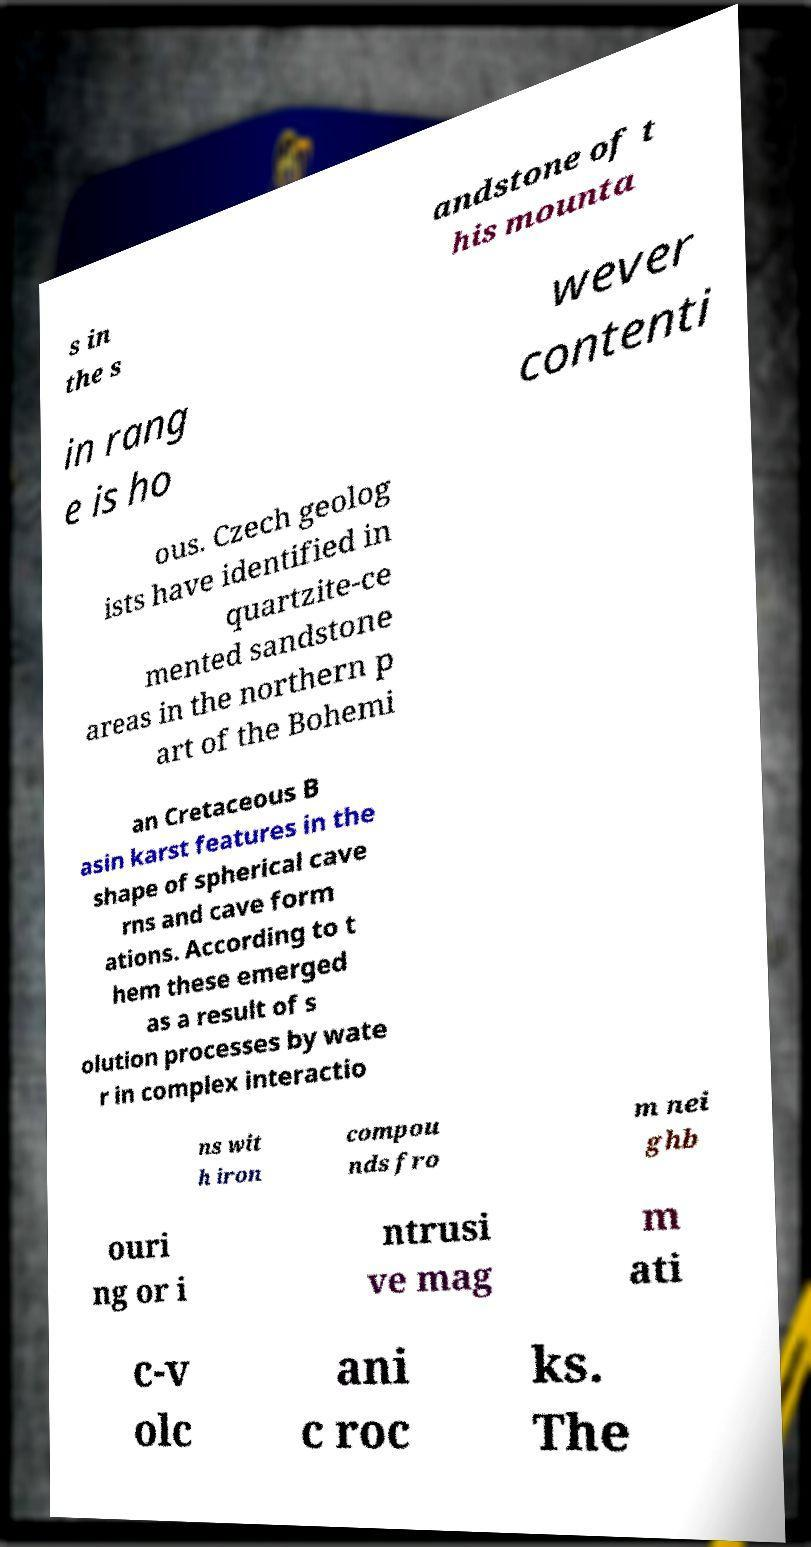Could you assist in decoding the text presented in this image and type it out clearly? s in the s andstone of t his mounta in rang e is ho wever contenti ous. Czech geolog ists have identified in quartzite-ce mented sandstone areas in the northern p art of the Bohemi an Cretaceous B asin karst features in the shape of spherical cave rns and cave form ations. According to t hem these emerged as a result of s olution processes by wate r in complex interactio ns wit h iron compou nds fro m nei ghb ouri ng or i ntrusi ve mag m ati c-v olc ani c roc ks. The 